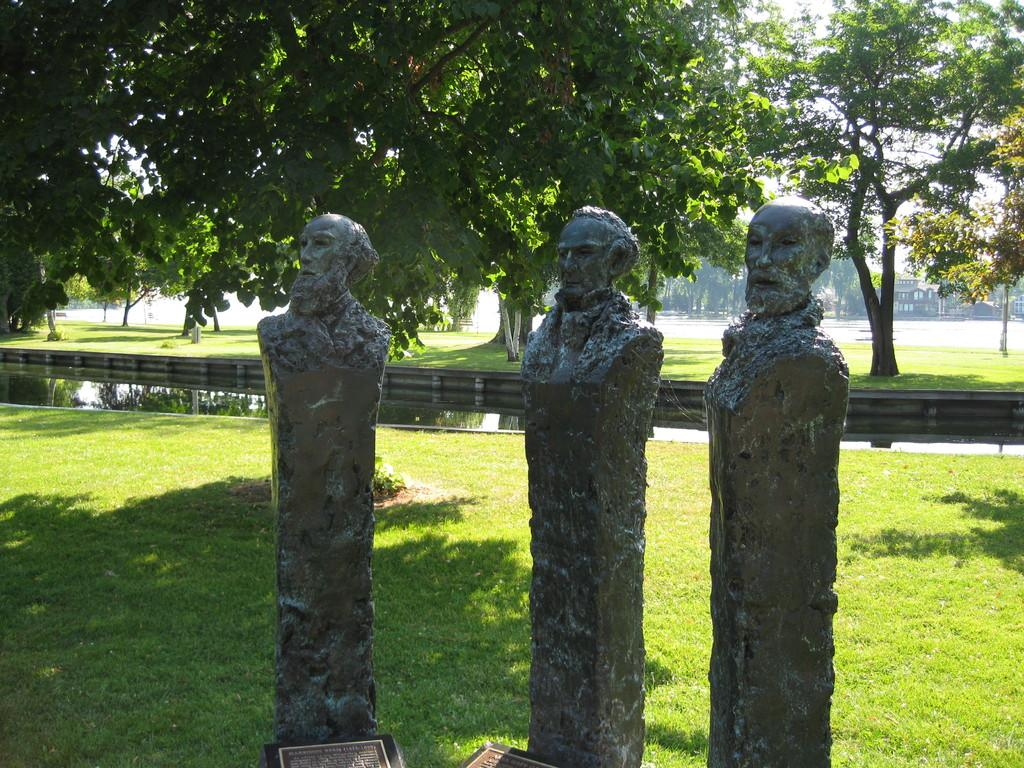What is the main subject in the image? There is a statue in the image. What can be found near the statue? There are information boards in the image. What is the landscape like in the image? The land is covered with grass. What can be seen in the background of the image? There is water, a building, and trees visible in the background of the image. What type of button can be seen on the statue in the image? There is no button present on the statue in the image. How does the statue attack the building in the background? The statue does not attack the building in the image; it is a stationary object. 